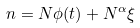Convert formula to latex. <formula><loc_0><loc_0><loc_500><loc_500>n = N \phi ( t ) + N ^ { \alpha } \xi</formula> 